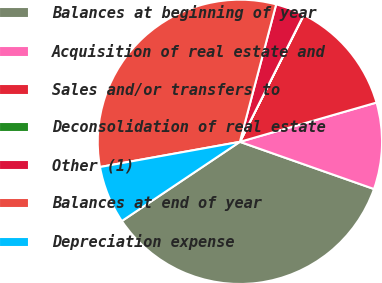Convert chart. <chart><loc_0><loc_0><loc_500><loc_500><pie_chart><fcel>Balances at beginning of year<fcel>Acquisition of real estate and<fcel>Sales and/or transfers to<fcel>Deconsolidation of real estate<fcel>Other (1)<fcel>Balances at end of year<fcel>Depreciation expense<nl><fcel>35.21%<fcel>9.84%<fcel>13.12%<fcel>0.02%<fcel>3.3%<fcel>31.94%<fcel>6.57%<nl></chart> 